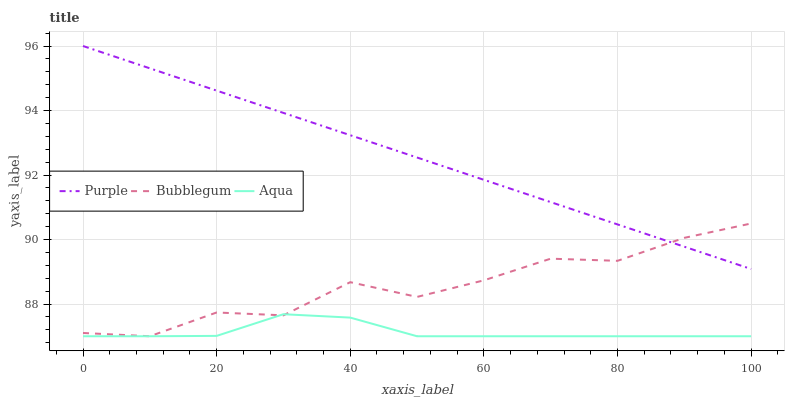Does Aqua have the minimum area under the curve?
Answer yes or no. Yes. Does Purple have the maximum area under the curve?
Answer yes or no. Yes. Does Bubblegum have the minimum area under the curve?
Answer yes or no. No. Does Bubblegum have the maximum area under the curve?
Answer yes or no. No. Is Purple the smoothest?
Answer yes or no. Yes. Is Bubblegum the roughest?
Answer yes or no. Yes. Is Aqua the smoothest?
Answer yes or no. No. Is Aqua the roughest?
Answer yes or no. No. Does Purple have the highest value?
Answer yes or no. Yes. Does Bubblegum have the highest value?
Answer yes or no. No. Is Aqua less than Purple?
Answer yes or no. Yes. Is Purple greater than Aqua?
Answer yes or no. Yes. Does Bubblegum intersect Aqua?
Answer yes or no. Yes. Is Bubblegum less than Aqua?
Answer yes or no. No. Is Bubblegum greater than Aqua?
Answer yes or no. No. Does Aqua intersect Purple?
Answer yes or no. No. 